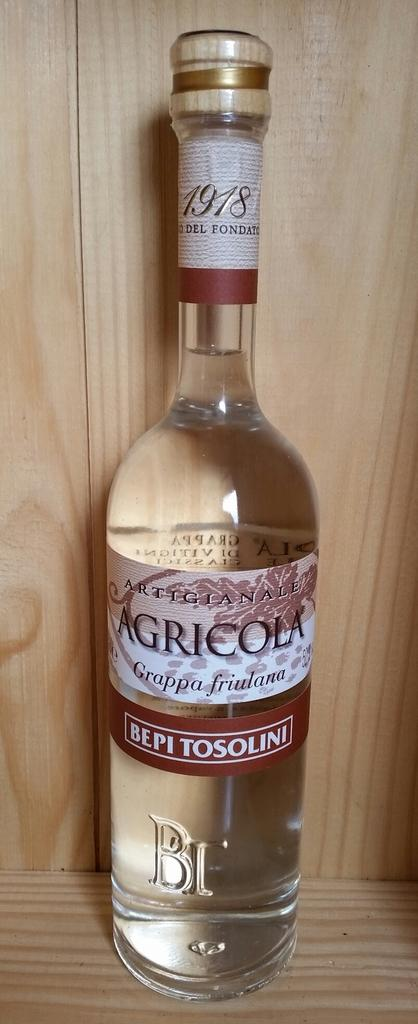Provide a one-sentence caption for the provided image. Agricola bottle sits alone on a wooden shelf. 